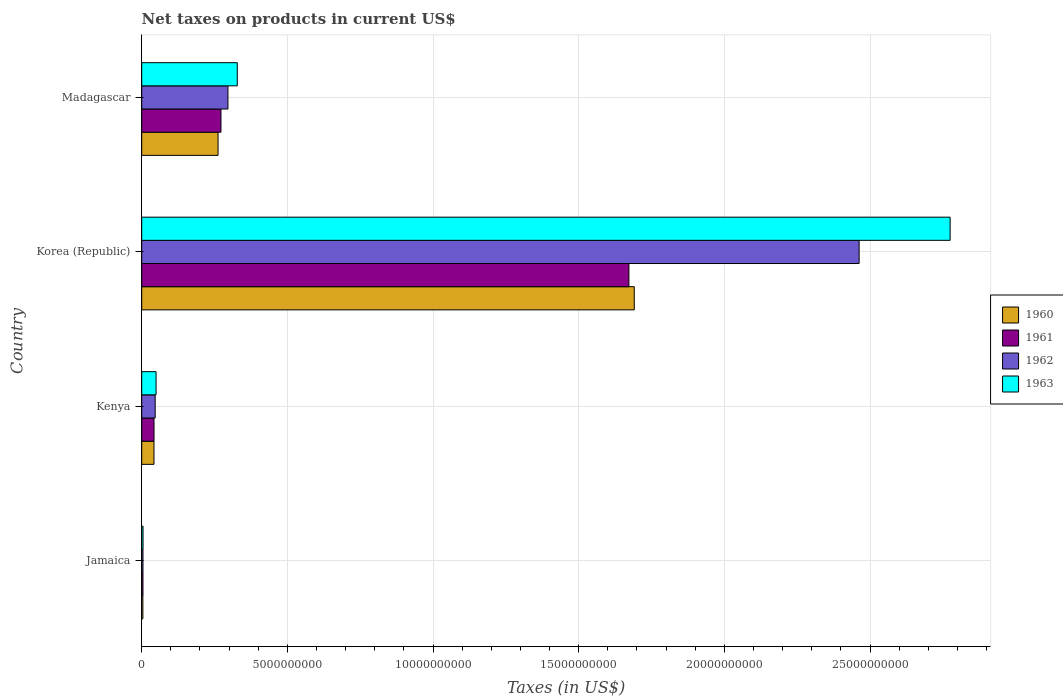How many different coloured bars are there?
Offer a terse response. 4. How many groups of bars are there?
Provide a succinct answer. 4. Are the number of bars per tick equal to the number of legend labels?
Provide a short and direct response. Yes. How many bars are there on the 3rd tick from the bottom?
Make the answer very short. 4. What is the label of the 1st group of bars from the top?
Offer a terse response. Madagascar. What is the net taxes on products in 1961 in Kenya?
Keep it short and to the point. 4.22e+08. Across all countries, what is the maximum net taxes on products in 1963?
Keep it short and to the point. 2.77e+1. Across all countries, what is the minimum net taxes on products in 1963?
Make the answer very short. 4.54e+07. In which country was the net taxes on products in 1963 minimum?
Ensure brevity in your answer.  Jamaica. What is the total net taxes on products in 1962 in the graph?
Make the answer very short. 2.81e+1. What is the difference between the net taxes on products in 1963 in Kenya and that in Madagascar?
Offer a terse response. -2.79e+09. What is the difference between the net taxes on products in 1960 in Jamaica and the net taxes on products in 1962 in Kenya?
Give a very brief answer. -4.22e+08. What is the average net taxes on products in 1960 per country?
Provide a short and direct response. 5.00e+09. What is the difference between the net taxes on products in 1962 and net taxes on products in 1960 in Madagascar?
Provide a short and direct response. 3.40e+08. In how many countries, is the net taxes on products in 1963 greater than 28000000000 US$?
Make the answer very short. 0. What is the ratio of the net taxes on products in 1962 in Jamaica to that in Madagascar?
Give a very brief answer. 0.01. Is the difference between the net taxes on products in 1962 in Kenya and Korea (Republic) greater than the difference between the net taxes on products in 1960 in Kenya and Korea (Republic)?
Ensure brevity in your answer.  No. What is the difference between the highest and the second highest net taxes on products in 1963?
Provide a succinct answer. 2.45e+1. What is the difference between the highest and the lowest net taxes on products in 1963?
Offer a terse response. 2.77e+1. Is it the case that in every country, the sum of the net taxes on products in 1962 and net taxes on products in 1961 is greater than the sum of net taxes on products in 1963 and net taxes on products in 1960?
Your answer should be compact. No. What does the 3rd bar from the top in Jamaica represents?
Provide a short and direct response. 1961. What does the 2nd bar from the bottom in Kenya represents?
Your answer should be compact. 1961. How many bars are there?
Provide a succinct answer. 16. Are all the bars in the graph horizontal?
Offer a terse response. Yes. How many countries are there in the graph?
Offer a very short reply. 4. What is the difference between two consecutive major ticks on the X-axis?
Give a very brief answer. 5.00e+09. Are the values on the major ticks of X-axis written in scientific E-notation?
Your response must be concise. No. Does the graph contain any zero values?
Offer a very short reply. No. Does the graph contain grids?
Make the answer very short. Yes. Where does the legend appear in the graph?
Your answer should be compact. Center right. How many legend labels are there?
Your response must be concise. 4. What is the title of the graph?
Provide a short and direct response. Net taxes on products in current US$. Does "2003" appear as one of the legend labels in the graph?
Your answer should be very brief. No. What is the label or title of the X-axis?
Provide a short and direct response. Taxes (in US$). What is the label or title of the Y-axis?
Your answer should be compact. Country. What is the Taxes (in US$) in 1960 in Jamaica?
Keep it short and to the point. 3.93e+07. What is the Taxes (in US$) in 1961 in Jamaica?
Make the answer very short. 4.26e+07. What is the Taxes (in US$) in 1962 in Jamaica?
Give a very brief answer. 4.35e+07. What is the Taxes (in US$) in 1963 in Jamaica?
Offer a very short reply. 4.54e+07. What is the Taxes (in US$) in 1960 in Kenya?
Your response must be concise. 4.21e+08. What is the Taxes (in US$) of 1961 in Kenya?
Your answer should be compact. 4.22e+08. What is the Taxes (in US$) in 1962 in Kenya?
Keep it short and to the point. 4.62e+08. What is the Taxes (in US$) in 1963 in Kenya?
Your answer should be compact. 4.93e+08. What is the Taxes (in US$) in 1960 in Korea (Republic)?
Provide a succinct answer. 1.69e+1. What is the Taxes (in US$) in 1961 in Korea (Republic)?
Give a very brief answer. 1.67e+1. What is the Taxes (in US$) of 1962 in Korea (Republic)?
Your answer should be compact. 2.46e+1. What is the Taxes (in US$) of 1963 in Korea (Republic)?
Your response must be concise. 2.77e+1. What is the Taxes (in US$) of 1960 in Madagascar?
Your answer should be very brief. 2.62e+09. What is the Taxes (in US$) in 1961 in Madagascar?
Provide a succinct answer. 2.72e+09. What is the Taxes (in US$) in 1962 in Madagascar?
Offer a very short reply. 2.96e+09. What is the Taxes (in US$) in 1963 in Madagascar?
Provide a short and direct response. 3.28e+09. Across all countries, what is the maximum Taxes (in US$) of 1960?
Your answer should be compact. 1.69e+1. Across all countries, what is the maximum Taxes (in US$) in 1961?
Offer a terse response. 1.67e+1. Across all countries, what is the maximum Taxes (in US$) in 1962?
Keep it short and to the point. 2.46e+1. Across all countries, what is the maximum Taxes (in US$) in 1963?
Your answer should be compact. 2.77e+1. Across all countries, what is the minimum Taxes (in US$) in 1960?
Make the answer very short. 3.93e+07. Across all countries, what is the minimum Taxes (in US$) of 1961?
Offer a very short reply. 4.26e+07. Across all countries, what is the minimum Taxes (in US$) of 1962?
Offer a terse response. 4.35e+07. Across all countries, what is the minimum Taxes (in US$) of 1963?
Your answer should be very brief. 4.54e+07. What is the total Taxes (in US$) in 1960 in the graph?
Make the answer very short. 2.00e+1. What is the total Taxes (in US$) in 1961 in the graph?
Offer a very short reply. 1.99e+1. What is the total Taxes (in US$) of 1962 in the graph?
Offer a very short reply. 2.81e+1. What is the total Taxes (in US$) of 1963 in the graph?
Make the answer very short. 3.16e+1. What is the difference between the Taxes (in US$) in 1960 in Jamaica and that in Kenya?
Give a very brief answer. -3.82e+08. What is the difference between the Taxes (in US$) in 1961 in Jamaica and that in Kenya?
Offer a very short reply. -3.79e+08. What is the difference between the Taxes (in US$) of 1962 in Jamaica and that in Kenya?
Provide a short and direct response. -4.18e+08. What is the difference between the Taxes (in US$) of 1963 in Jamaica and that in Kenya?
Provide a short and direct response. -4.48e+08. What is the difference between the Taxes (in US$) in 1960 in Jamaica and that in Korea (Republic)?
Give a very brief answer. -1.69e+1. What is the difference between the Taxes (in US$) of 1961 in Jamaica and that in Korea (Republic)?
Your answer should be compact. -1.67e+1. What is the difference between the Taxes (in US$) of 1962 in Jamaica and that in Korea (Republic)?
Keep it short and to the point. -2.46e+1. What is the difference between the Taxes (in US$) in 1963 in Jamaica and that in Korea (Republic)?
Offer a very short reply. -2.77e+1. What is the difference between the Taxes (in US$) in 1960 in Jamaica and that in Madagascar?
Your answer should be compact. -2.58e+09. What is the difference between the Taxes (in US$) of 1961 in Jamaica and that in Madagascar?
Make the answer very short. -2.68e+09. What is the difference between the Taxes (in US$) of 1962 in Jamaica and that in Madagascar?
Offer a very short reply. -2.92e+09. What is the difference between the Taxes (in US$) in 1963 in Jamaica and that in Madagascar?
Provide a succinct answer. -3.23e+09. What is the difference between the Taxes (in US$) in 1960 in Kenya and that in Korea (Republic)?
Provide a succinct answer. -1.65e+1. What is the difference between the Taxes (in US$) in 1961 in Kenya and that in Korea (Republic)?
Keep it short and to the point. -1.63e+1. What is the difference between the Taxes (in US$) of 1962 in Kenya and that in Korea (Republic)?
Provide a succinct answer. -2.42e+1. What is the difference between the Taxes (in US$) in 1963 in Kenya and that in Korea (Republic)?
Provide a short and direct response. -2.73e+1. What is the difference between the Taxes (in US$) of 1960 in Kenya and that in Madagascar?
Provide a short and direct response. -2.20e+09. What is the difference between the Taxes (in US$) of 1961 in Kenya and that in Madagascar?
Provide a short and direct response. -2.30e+09. What is the difference between the Taxes (in US$) in 1962 in Kenya and that in Madagascar?
Offer a very short reply. -2.50e+09. What is the difference between the Taxes (in US$) in 1963 in Kenya and that in Madagascar?
Make the answer very short. -2.79e+09. What is the difference between the Taxes (in US$) of 1960 in Korea (Republic) and that in Madagascar?
Your answer should be compact. 1.43e+1. What is the difference between the Taxes (in US$) of 1961 in Korea (Republic) and that in Madagascar?
Provide a short and direct response. 1.40e+1. What is the difference between the Taxes (in US$) of 1962 in Korea (Republic) and that in Madagascar?
Offer a very short reply. 2.17e+1. What is the difference between the Taxes (in US$) in 1963 in Korea (Republic) and that in Madagascar?
Your answer should be very brief. 2.45e+1. What is the difference between the Taxes (in US$) of 1960 in Jamaica and the Taxes (in US$) of 1961 in Kenya?
Make the answer very short. -3.83e+08. What is the difference between the Taxes (in US$) in 1960 in Jamaica and the Taxes (in US$) in 1962 in Kenya?
Ensure brevity in your answer.  -4.22e+08. What is the difference between the Taxes (in US$) in 1960 in Jamaica and the Taxes (in US$) in 1963 in Kenya?
Make the answer very short. -4.54e+08. What is the difference between the Taxes (in US$) in 1961 in Jamaica and the Taxes (in US$) in 1962 in Kenya?
Your response must be concise. -4.19e+08. What is the difference between the Taxes (in US$) of 1961 in Jamaica and the Taxes (in US$) of 1963 in Kenya?
Make the answer very short. -4.50e+08. What is the difference between the Taxes (in US$) of 1962 in Jamaica and the Taxes (in US$) of 1963 in Kenya?
Offer a terse response. -4.50e+08. What is the difference between the Taxes (in US$) in 1960 in Jamaica and the Taxes (in US$) in 1961 in Korea (Republic)?
Ensure brevity in your answer.  -1.67e+1. What is the difference between the Taxes (in US$) in 1960 in Jamaica and the Taxes (in US$) in 1962 in Korea (Republic)?
Your response must be concise. -2.46e+1. What is the difference between the Taxes (in US$) in 1960 in Jamaica and the Taxes (in US$) in 1963 in Korea (Republic)?
Your response must be concise. -2.77e+1. What is the difference between the Taxes (in US$) of 1961 in Jamaica and the Taxes (in US$) of 1962 in Korea (Republic)?
Provide a succinct answer. -2.46e+1. What is the difference between the Taxes (in US$) of 1961 in Jamaica and the Taxes (in US$) of 1963 in Korea (Republic)?
Provide a succinct answer. -2.77e+1. What is the difference between the Taxes (in US$) of 1962 in Jamaica and the Taxes (in US$) of 1963 in Korea (Republic)?
Give a very brief answer. -2.77e+1. What is the difference between the Taxes (in US$) of 1960 in Jamaica and the Taxes (in US$) of 1961 in Madagascar?
Provide a succinct answer. -2.68e+09. What is the difference between the Taxes (in US$) of 1960 in Jamaica and the Taxes (in US$) of 1962 in Madagascar?
Your answer should be compact. -2.92e+09. What is the difference between the Taxes (in US$) of 1960 in Jamaica and the Taxes (in US$) of 1963 in Madagascar?
Your answer should be compact. -3.24e+09. What is the difference between the Taxes (in US$) of 1961 in Jamaica and the Taxes (in US$) of 1962 in Madagascar?
Ensure brevity in your answer.  -2.92e+09. What is the difference between the Taxes (in US$) in 1961 in Jamaica and the Taxes (in US$) in 1963 in Madagascar?
Offer a terse response. -3.24e+09. What is the difference between the Taxes (in US$) of 1962 in Jamaica and the Taxes (in US$) of 1963 in Madagascar?
Offer a terse response. -3.24e+09. What is the difference between the Taxes (in US$) of 1960 in Kenya and the Taxes (in US$) of 1961 in Korea (Republic)?
Make the answer very short. -1.63e+1. What is the difference between the Taxes (in US$) in 1960 in Kenya and the Taxes (in US$) in 1962 in Korea (Republic)?
Your answer should be compact. -2.42e+1. What is the difference between the Taxes (in US$) of 1960 in Kenya and the Taxes (in US$) of 1963 in Korea (Republic)?
Offer a very short reply. -2.73e+1. What is the difference between the Taxes (in US$) of 1961 in Kenya and the Taxes (in US$) of 1962 in Korea (Republic)?
Make the answer very short. -2.42e+1. What is the difference between the Taxes (in US$) in 1961 in Kenya and the Taxes (in US$) in 1963 in Korea (Republic)?
Make the answer very short. -2.73e+1. What is the difference between the Taxes (in US$) of 1962 in Kenya and the Taxes (in US$) of 1963 in Korea (Republic)?
Offer a very short reply. -2.73e+1. What is the difference between the Taxes (in US$) of 1960 in Kenya and the Taxes (in US$) of 1961 in Madagascar?
Give a very brief answer. -2.30e+09. What is the difference between the Taxes (in US$) in 1960 in Kenya and the Taxes (in US$) in 1962 in Madagascar?
Ensure brevity in your answer.  -2.54e+09. What is the difference between the Taxes (in US$) of 1960 in Kenya and the Taxes (in US$) of 1963 in Madagascar?
Keep it short and to the point. -2.86e+09. What is the difference between the Taxes (in US$) of 1961 in Kenya and the Taxes (in US$) of 1962 in Madagascar?
Keep it short and to the point. -2.54e+09. What is the difference between the Taxes (in US$) of 1961 in Kenya and the Taxes (in US$) of 1963 in Madagascar?
Keep it short and to the point. -2.86e+09. What is the difference between the Taxes (in US$) in 1962 in Kenya and the Taxes (in US$) in 1963 in Madagascar?
Your response must be concise. -2.82e+09. What is the difference between the Taxes (in US$) in 1960 in Korea (Republic) and the Taxes (in US$) in 1961 in Madagascar?
Make the answer very short. 1.42e+1. What is the difference between the Taxes (in US$) of 1960 in Korea (Republic) and the Taxes (in US$) of 1962 in Madagascar?
Offer a terse response. 1.39e+1. What is the difference between the Taxes (in US$) of 1960 in Korea (Republic) and the Taxes (in US$) of 1963 in Madagascar?
Make the answer very short. 1.36e+1. What is the difference between the Taxes (in US$) in 1961 in Korea (Republic) and the Taxes (in US$) in 1962 in Madagascar?
Your response must be concise. 1.38e+1. What is the difference between the Taxes (in US$) in 1961 in Korea (Republic) and the Taxes (in US$) in 1963 in Madagascar?
Ensure brevity in your answer.  1.34e+1. What is the difference between the Taxes (in US$) in 1962 in Korea (Republic) and the Taxes (in US$) in 1963 in Madagascar?
Your answer should be compact. 2.13e+1. What is the average Taxes (in US$) of 1960 per country?
Your response must be concise. 5.00e+09. What is the average Taxes (in US$) in 1961 per country?
Your answer should be compact. 4.98e+09. What is the average Taxes (in US$) in 1962 per country?
Provide a short and direct response. 7.02e+09. What is the average Taxes (in US$) of 1963 per country?
Your answer should be compact. 7.89e+09. What is the difference between the Taxes (in US$) of 1960 and Taxes (in US$) of 1961 in Jamaica?
Your response must be concise. -3.30e+06. What is the difference between the Taxes (in US$) in 1960 and Taxes (in US$) in 1962 in Jamaica?
Keep it short and to the point. -4.20e+06. What is the difference between the Taxes (in US$) in 1960 and Taxes (in US$) in 1963 in Jamaica?
Your response must be concise. -6.10e+06. What is the difference between the Taxes (in US$) in 1961 and Taxes (in US$) in 1962 in Jamaica?
Ensure brevity in your answer.  -9.00e+05. What is the difference between the Taxes (in US$) of 1961 and Taxes (in US$) of 1963 in Jamaica?
Ensure brevity in your answer.  -2.80e+06. What is the difference between the Taxes (in US$) in 1962 and Taxes (in US$) in 1963 in Jamaica?
Give a very brief answer. -1.90e+06. What is the difference between the Taxes (in US$) in 1960 and Taxes (in US$) in 1961 in Kenya?
Your answer should be very brief. -1.00e+06. What is the difference between the Taxes (in US$) of 1960 and Taxes (in US$) of 1962 in Kenya?
Keep it short and to the point. -4.09e+07. What is the difference between the Taxes (in US$) in 1960 and Taxes (in US$) in 1963 in Kenya?
Your response must be concise. -7.21e+07. What is the difference between the Taxes (in US$) of 1961 and Taxes (in US$) of 1962 in Kenya?
Ensure brevity in your answer.  -3.99e+07. What is the difference between the Taxes (in US$) in 1961 and Taxes (in US$) in 1963 in Kenya?
Offer a very short reply. -7.11e+07. What is the difference between the Taxes (in US$) in 1962 and Taxes (in US$) in 1963 in Kenya?
Ensure brevity in your answer.  -3.12e+07. What is the difference between the Taxes (in US$) of 1960 and Taxes (in US$) of 1961 in Korea (Republic)?
Your response must be concise. 1.84e+08. What is the difference between the Taxes (in US$) in 1960 and Taxes (in US$) in 1962 in Korea (Republic)?
Make the answer very short. -7.72e+09. What is the difference between the Taxes (in US$) in 1960 and Taxes (in US$) in 1963 in Korea (Republic)?
Offer a very short reply. -1.08e+1. What is the difference between the Taxes (in US$) of 1961 and Taxes (in US$) of 1962 in Korea (Republic)?
Keep it short and to the point. -7.90e+09. What is the difference between the Taxes (in US$) in 1961 and Taxes (in US$) in 1963 in Korea (Republic)?
Give a very brief answer. -1.10e+1. What is the difference between the Taxes (in US$) of 1962 and Taxes (in US$) of 1963 in Korea (Republic)?
Your answer should be compact. -3.12e+09. What is the difference between the Taxes (in US$) of 1960 and Taxes (in US$) of 1961 in Madagascar?
Offer a very short reply. -1.00e+08. What is the difference between the Taxes (in US$) of 1960 and Taxes (in US$) of 1962 in Madagascar?
Make the answer very short. -3.40e+08. What is the difference between the Taxes (in US$) of 1960 and Taxes (in US$) of 1963 in Madagascar?
Your response must be concise. -6.60e+08. What is the difference between the Taxes (in US$) in 1961 and Taxes (in US$) in 1962 in Madagascar?
Your response must be concise. -2.40e+08. What is the difference between the Taxes (in US$) in 1961 and Taxes (in US$) in 1963 in Madagascar?
Your answer should be compact. -5.60e+08. What is the difference between the Taxes (in US$) in 1962 and Taxes (in US$) in 1963 in Madagascar?
Ensure brevity in your answer.  -3.20e+08. What is the ratio of the Taxes (in US$) of 1960 in Jamaica to that in Kenya?
Ensure brevity in your answer.  0.09. What is the ratio of the Taxes (in US$) in 1961 in Jamaica to that in Kenya?
Keep it short and to the point. 0.1. What is the ratio of the Taxes (in US$) of 1962 in Jamaica to that in Kenya?
Offer a terse response. 0.09. What is the ratio of the Taxes (in US$) of 1963 in Jamaica to that in Kenya?
Your answer should be compact. 0.09. What is the ratio of the Taxes (in US$) of 1960 in Jamaica to that in Korea (Republic)?
Provide a short and direct response. 0. What is the ratio of the Taxes (in US$) in 1961 in Jamaica to that in Korea (Republic)?
Your answer should be compact. 0. What is the ratio of the Taxes (in US$) in 1962 in Jamaica to that in Korea (Republic)?
Your response must be concise. 0. What is the ratio of the Taxes (in US$) in 1963 in Jamaica to that in Korea (Republic)?
Ensure brevity in your answer.  0. What is the ratio of the Taxes (in US$) in 1960 in Jamaica to that in Madagascar?
Offer a terse response. 0.01. What is the ratio of the Taxes (in US$) in 1961 in Jamaica to that in Madagascar?
Offer a very short reply. 0.02. What is the ratio of the Taxes (in US$) of 1962 in Jamaica to that in Madagascar?
Provide a short and direct response. 0.01. What is the ratio of the Taxes (in US$) in 1963 in Jamaica to that in Madagascar?
Offer a very short reply. 0.01. What is the ratio of the Taxes (in US$) in 1960 in Kenya to that in Korea (Republic)?
Make the answer very short. 0.02. What is the ratio of the Taxes (in US$) in 1961 in Kenya to that in Korea (Republic)?
Your answer should be very brief. 0.03. What is the ratio of the Taxes (in US$) of 1962 in Kenya to that in Korea (Republic)?
Your answer should be very brief. 0.02. What is the ratio of the Taxes (in US$) in 1963 in Kenya to that in Korea (Republic)?
Give a very brief answer. 0.02. What is the ratio of the Taxes (in US$) in 1960 in Kenya to that in Madagascar?
Give a very brief answer. 0.16. What is the ratio of the Taxes (in US$) in 1961 in Kenya to that in Madagascar?
Keep it short and to the point. 0.16. What is the ratio of the Taxes (in US$) in 1962 in Kenya to that in Madagascar?
Keep it short and to the point. 0.16. What is the ratio of the Taxes (in US$) of 1963 in Kenya to that in Madagascar?
Provide a short and direct response. 0.15. What is the ratio of the Taxes (in US$) of 1960 in Korea (Republic) to that in Madagascar?
Offer a very short reply. 6.45. What is the ratio of the Taxes (in US$) of 1961 in Korea (Republic) to that in Madagascar?
Your response must be concise. 6.15. What is the ratio of the Taxes (in US$) of 1962 in Korea (Republic) to that in Madagascar?
Make the answer very short. 8.32. What is the ratio of the Taxes (in US$) of 1963 in Korea (Republic) to that in Madagascar?
Offer a terse response. 8.46. What is the difference between the highest and the second highest Taxes (in US$) of 1960?
Your answer should be compact. 1.43e+1. What is the difference between the highest and the second highest Taxes (in US$) of 1961?
Provide a short and direct response. 1.40e+1. What is the difference between the highest and the second highest Taxes (in US$) in 1962?
Offer a terse response. 2.17e+1. What is the difference between the highest and the second highest Taxes (in US$) of 1963?
Give a very brief answer. 2.45e+1. What is the difference between the highest and the lowest Taxes (in US$) in 1960?
Offer a terse response. 1.69e+1. What is the difference between the highest and the lowest Taxes (in US$) of 1961?
Give a very brief answer. 1.67e+1. What is the difference between the highest and the lowest Taxes (in US$) of 1962?
Provide a succinct answer. 2.46e+1. What is the difference between the highest and the lowest Taxes (in US$) of 1963?
Offer a very short reply. 2.77e+1. 